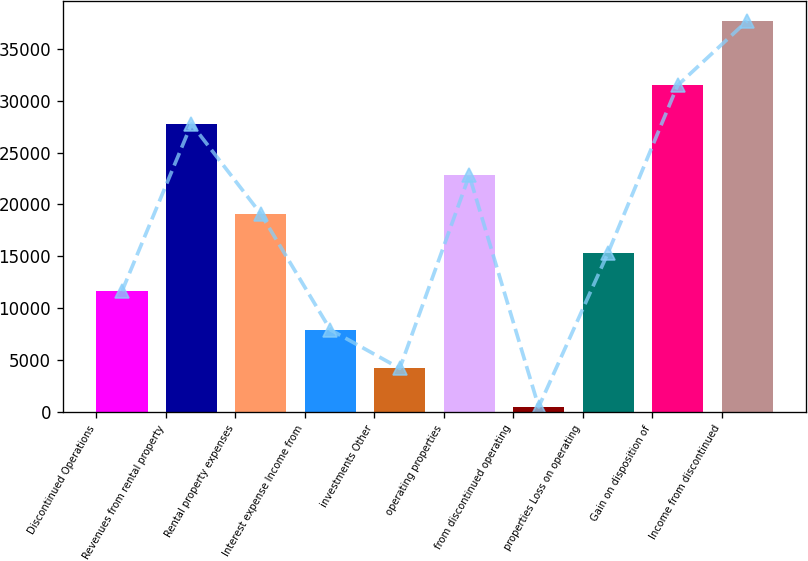<chart> <loc_0><loc_0><loc_500><loc_500><bar_chart><fcel>Discontinued Operations<fcel>Revenues from rental property<fcel>Rental property expenses<fcel>Interest expense Income from<fcel>investments Other<fcel>operating properties<fcel>from discontinued operating<fcel>properties Loss on operating<fcel>Gain on disposition of<fcel>Income from discontinued<nl><fcel>11637.5<fcel>27757<fcel>19078.5<fcel>7917<fcel>4196.5<fcel>22799<fcel>476<fcel>15358<fcel>31477.5<fcel>37681<nl></chart> 